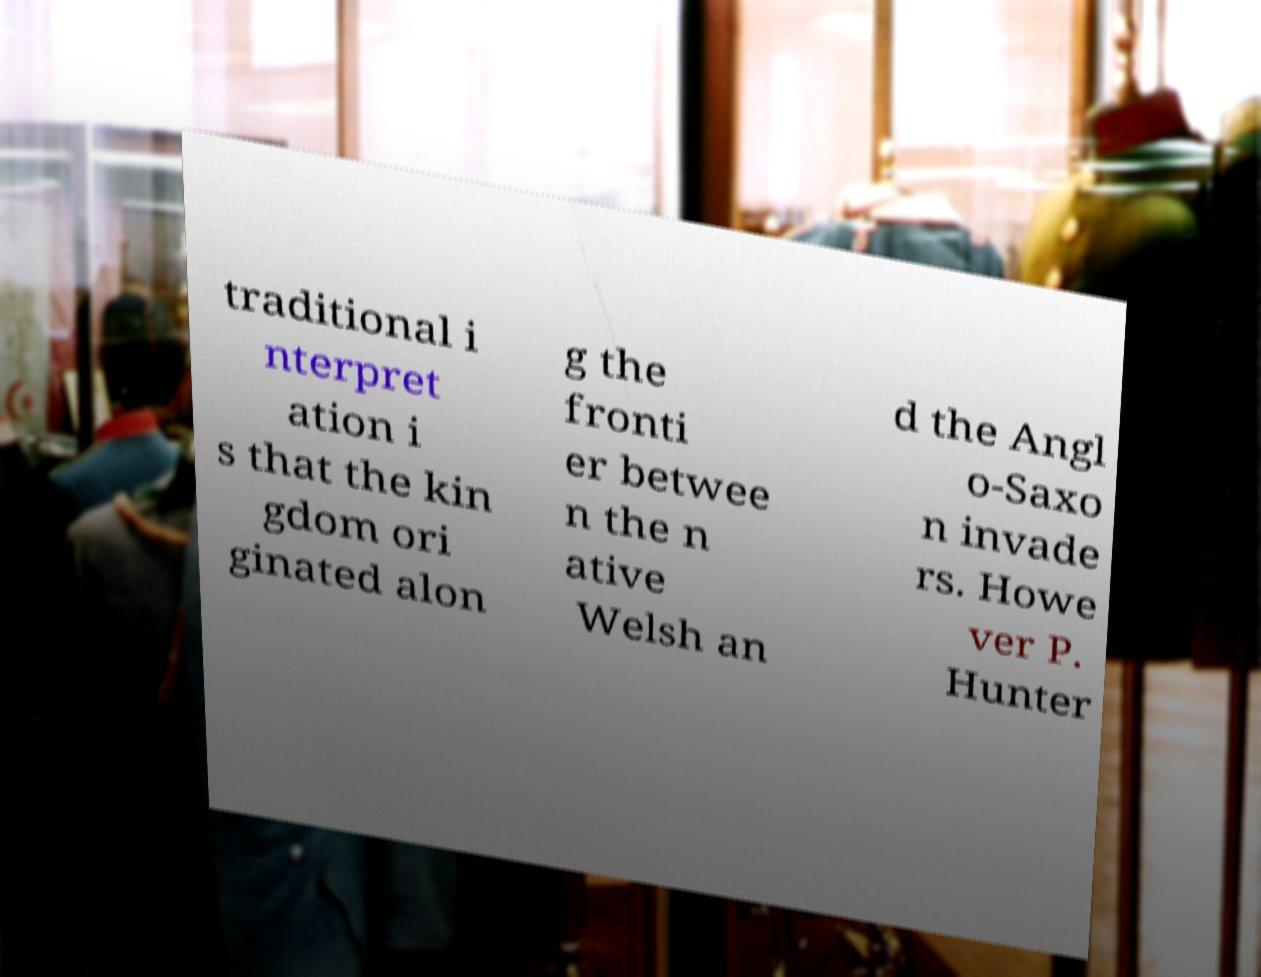Can you read and provide the text displayed in the image?This photo seems to have some interesting text. Can you extract and type it out for me? traditional i nterpret ation i s that the kin gdom ori ginated alon g the fronti er betwee n the n ative Welsh an d the Angl o-Saxo n invade rs. Howe ver P. Hunter 